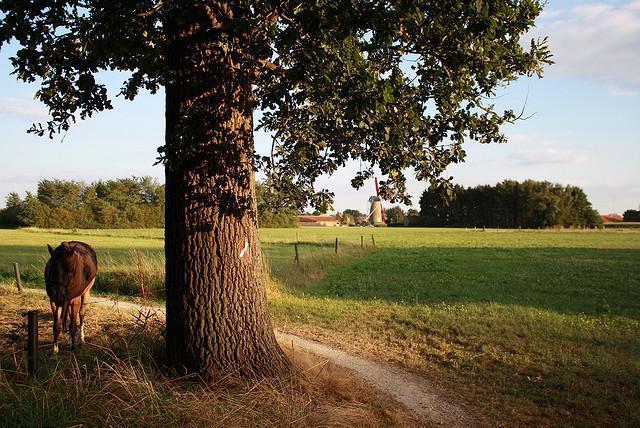How many horses are there?
Give a very brief answer. 1. 